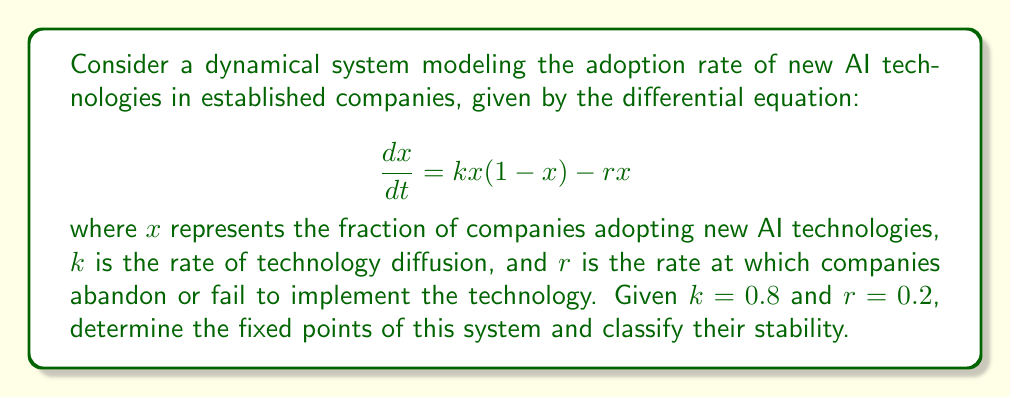Show me your answer to this math problem. To find the fixed points of this dynamical system, we need to set the derivative equal to zero and solve for x:

1) Set $\frac{dx}{dt} = 0$:
   $$ 0 = kx(1-x) - rx $$

2) Substitute the given values $k=0.8$ and $r=0.2$:
   $$ 0 = 0.8x(1-x) - 0.2x $$

3) Expand the equation:
   $$ 0 = 0.8x - 0.8x^2 - 0.2x $$
   $$ 0 = 0.6x - 0.8x^2 $$

4) Factor out x:
   $$ 0 = x(0.6 - 0.8x) $$

5) Solve for x:
   $x = 0$ or $0.6 - 0.8x = 0$
   
   For the second equation:
   $0.6 = 0.8x$
   $x = 0.75$

6) Therefore, the fixed points are $x_1 = 0$ and $x_2 = 0.75$

To classify their stability, we need to evaluate the derivative of $\frac{dx}{dt}$ at each fixed point:

$\frac{d}{dx}(\frac{dx}{dt}) = k(1-2x) - r = 0.8(1-2x) - 0.2$

At $x_1 = 0$: $0.8(1-2(0)) - 0.2 = 0.6 > 0$, so this is an unstable fixed point.
At $x_2 = 0.75$: $0.8(1-2(0.75)) - 0.2 = -0.6 < 0$, so this is a stable fixed point.
Answer: Fixed points: $x_1 = 0$ (unstable), $x_2 = 0.75$ (stable) 